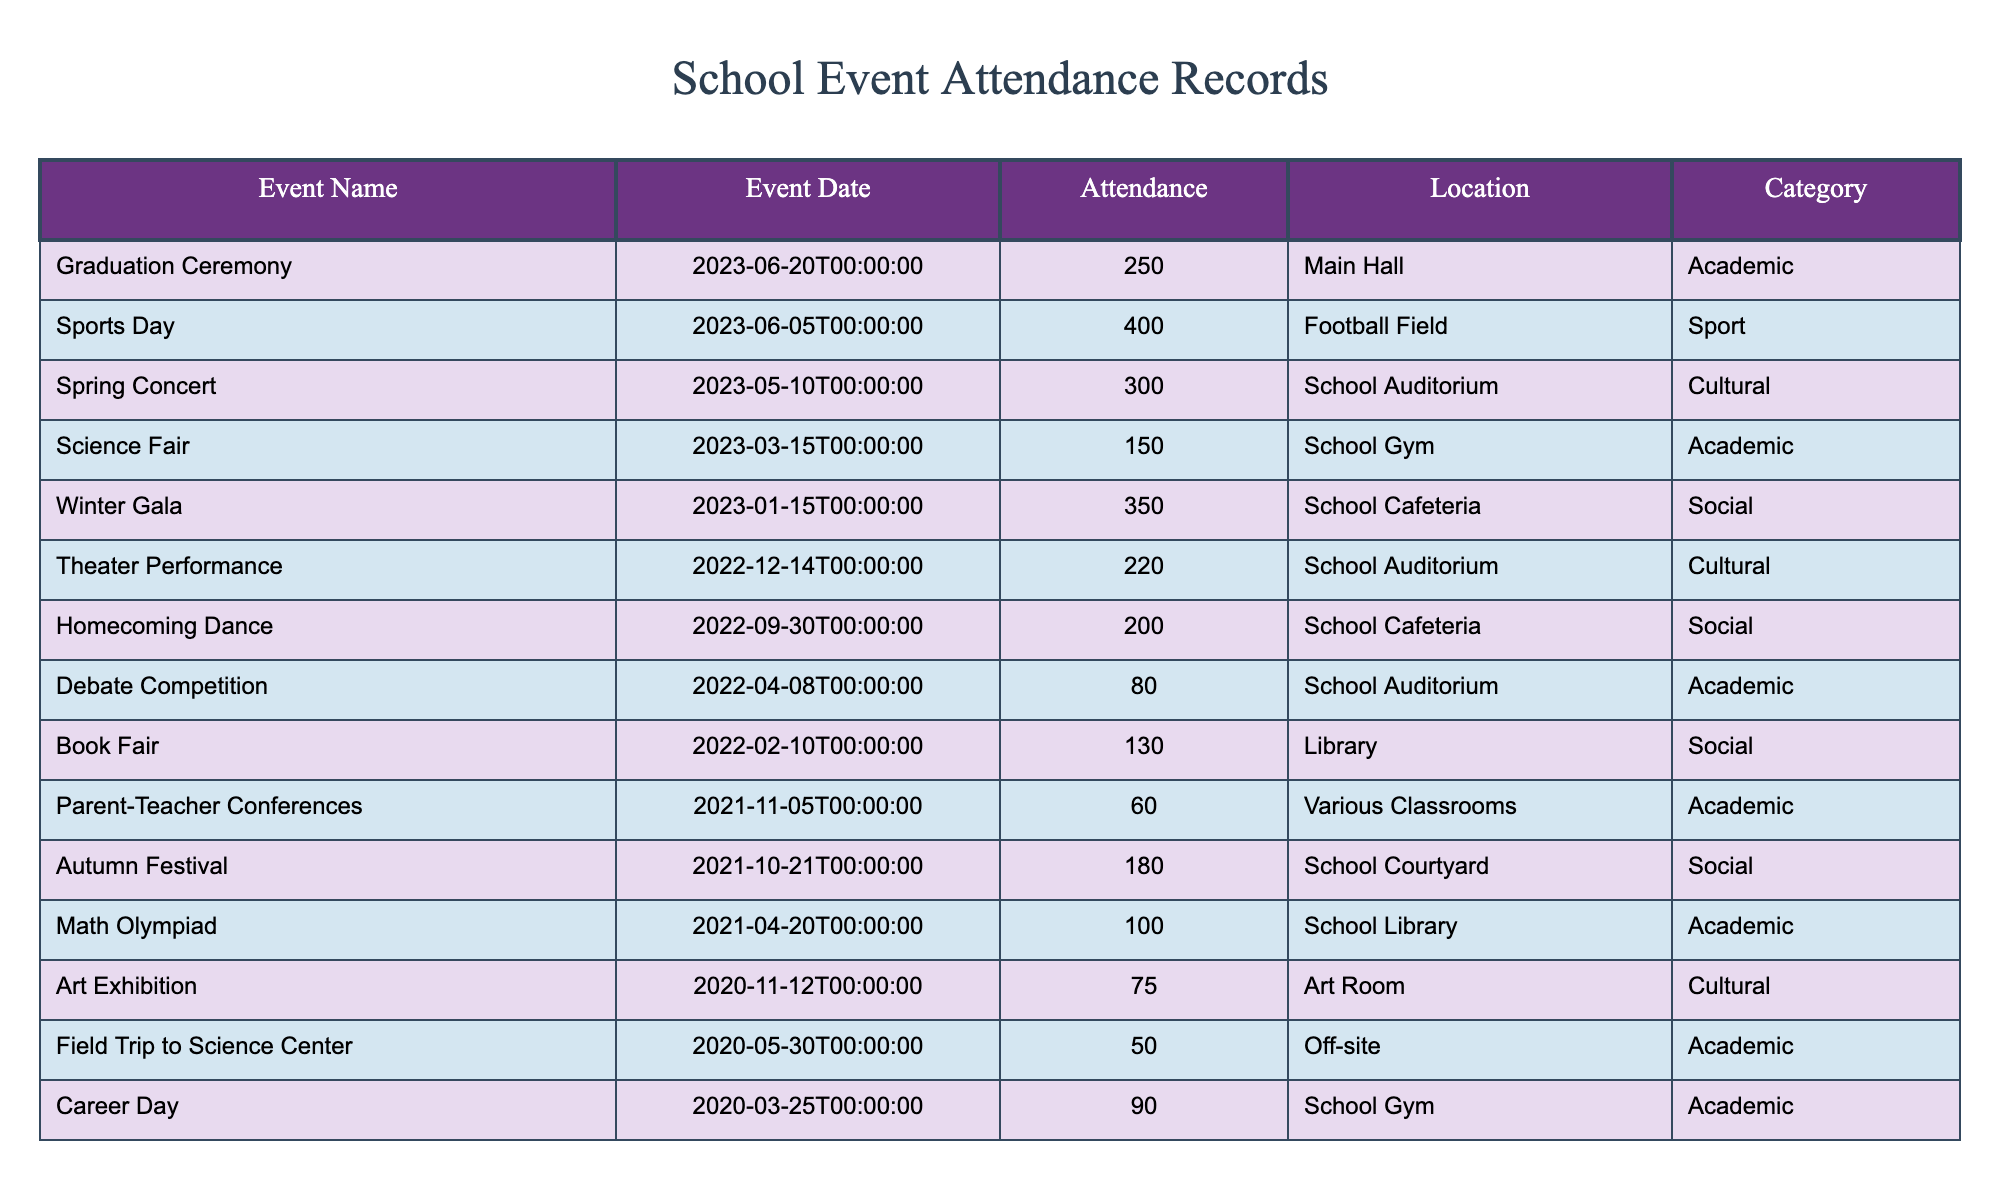What is the total attendance for all events in 2023? The events in 2023 listed in the table are the Science Fair, Spring Concert, Sports Day, Graduation Ceremony, and Winter Gala. The attendances for these events are 150, 300, 400, 250, and 350 respectively. Summing these values gives us 150 + 300 + 400 + 250 + 350 = 1450.
Answer: 1450 Which event had the highest attendance? The event with the highest attendance in the table is Sports Day with an attendance of 400, which is greater than the attendance values of all other events listed.
Answer: Sports Day How many events had an attendance of over 200? The events with attendance over 200 are the Homecoming Dance (200), Spring Concert (300), Sports Day (400), Graduation Ceremony (250), and Winter Gala (350). Counting these events gives a total of 5.
Answer: 5 Which category had the least attendance at a single event? The event with the least attendance in the table is the Field Trip to Science Center, which had an attendance of 50 and falls under the Academic category. This is the lowest attendance recorded compared to all other events.
Answer: 50 Did the Art Exhibition have a higher attendance than the Math Olympiad? The Art Exhibition had an attendance of 75, while the Math Olympiad had 100. Since 75 is less than 100, the statement is false.
Answer: No What was the average attendance for cultural events? The cultural events listed are the Spring Concert (300), Art Exhibition (75), Theater Performance (220), and Winter Gala (350). Therefore, the total attendance for these events is 300 + 75 + 220 + 350 = 945. Since there are 4 cultural events, the average attendance is 945 / 4 = 236.25.
Answer: 236.25 How many events took place in the Auditorium? The events in the Auditorium are the Spring Concert, Theater Performance, and Debate Competition. Counting these events results in a total of 3 events held in the Auditorium.
Answer: 3 Was there any event with attendance of exactly 90? There is an event called Career Day that had an attendance of exactly 90, therefore the statement is true.
Answer: Yes 